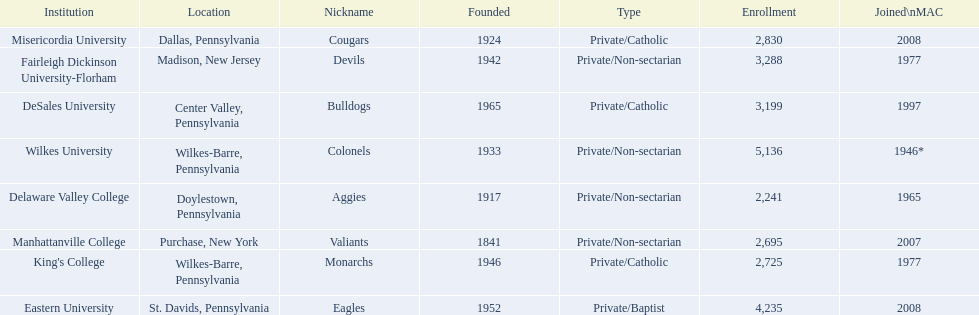Name each institution with enrollment numbers above 4,000? Eastern University, Wilkes University. 